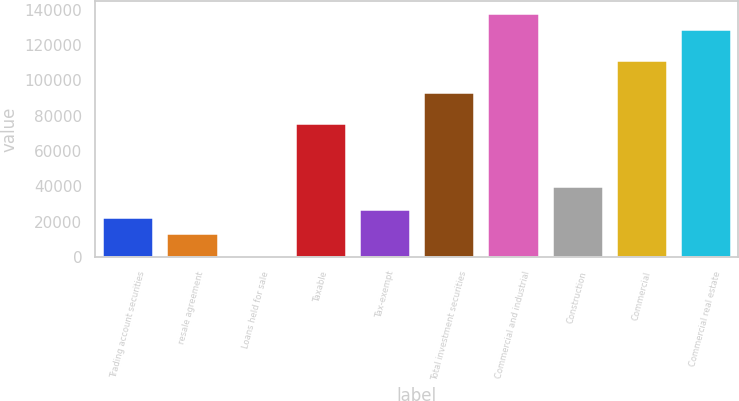Convert chart to OTSL. <chart><loc_0><loc_0><loc_500><loc_500><bar_chart><fcel>Trading account securities<fcel>resale agreement<fcel>Loans held for sale<fcel>Taxable<fcel>Tax-exempt<fcel>Total investment securities<fcel>Commercial and industrial<fcel>Construction<fcel>Commercial<fcel>Commercial real estate<nl><fcel>22537<fcel>13667<fcel>362<fcel>75757<fcel>26972<fcel>93497<fcel>137847<fcel>40277<fcel>111237<fcel>128977<nl></chart> 